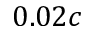Convert formula to latex. <formula><loc_0><loc_0><loc_500><loc_500>0 . 0 2 c</formula> 